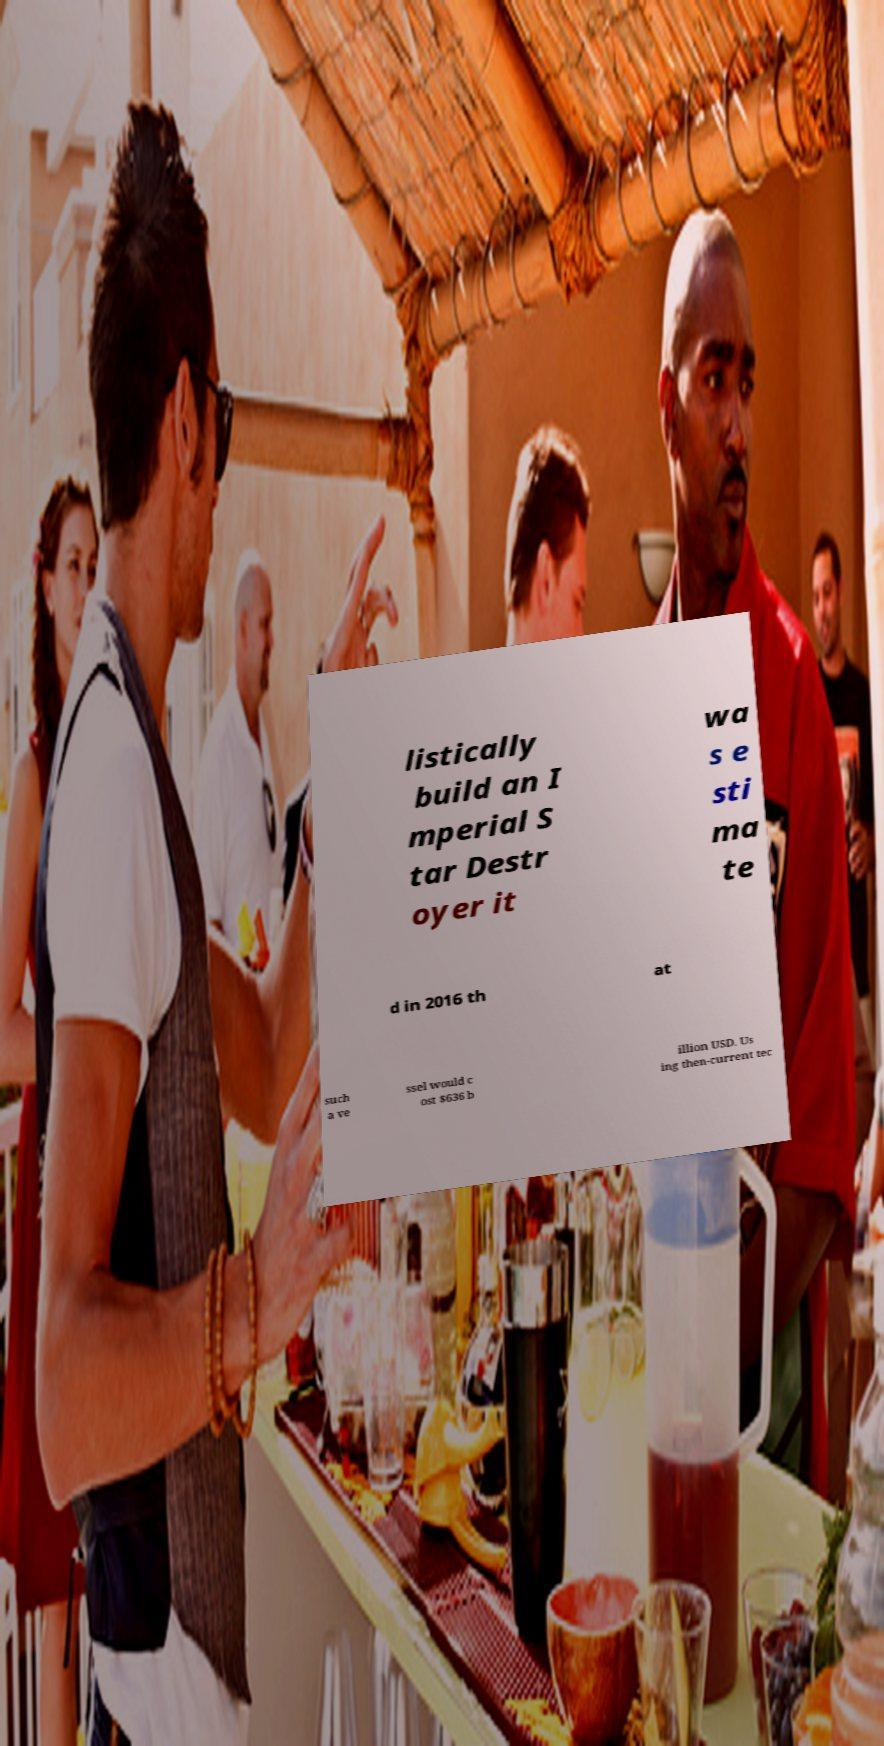Could you extract and type out the text from this image? listically build an I mperial S tar Destr oyer it wa s e sti ma te d in 2016 th at such a ve ssel would c ost $636 b illion USD. Us ing then-current tec 